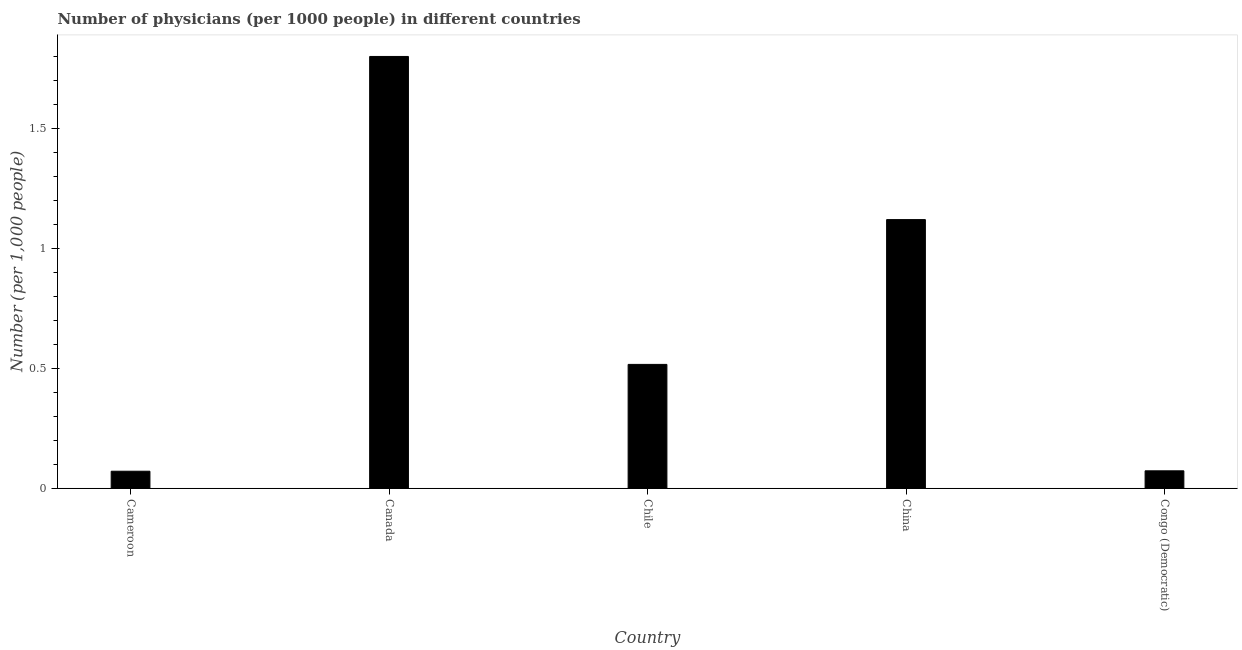Does the graph contain grids?
Your response must be concise. No. What is the title of the graph?
Your answer should be compact. Number of physicians (per 1000 people) in different countries. What is the label or title of the Y-axis?
Offer a very short reply. Number (per 1,0 people). What is the number of physicians in Congo (Democratic)?
Your answer should be very brief. 0.07. Across all countries, what is the maximum number of physicians?
Your answer should be compact. 1.8. Across all countries, what is the minimum number of physicians?
Your response must be concise. 0.07. In which country was the number of physicians maximum?
Offer a very short reply. Canada. In which country was the number of physicians minimum?
Keep it short and to the point. Cameroon. What is the sum of the number of physicians?
Offer a very short reply. 3.58. What is the difference between the number of physicians in Cameroon and Congo (Democratic)?
Provide a succinct answer. -0. What is the average number of physicians per country?
Offer a very short reply. 0.72. What is the median number of physicians?
Your response must be concise. 0.52. In how many countries, is the number of physicians greater than 0.6 ?
Provide a succinct answer. 2. Is the number of physicians in China less than that in Congo (Democratic)?
Offer a terse response. No. What is the difference between the highest and the second highest number of physicians?
Provide a short and direct response. 0.68. Is the sum of the number of physicians in Cameroon and Chile greater than the maximum number of physicians across all countries?
Keep it short and to the point. No. What is the difference between the highest and the lowest number of physicians?
Offer a terse response. 1.73. In how many countries, is the number of physicians greater than the average number of physicians taken over all countries?
Provide a succinct answer. 2. Are the values on the major ticks of Y-axis written in scientific E-notation?
Your answer should be compact. No. What is the Number (per 1,000 people) of Cameroon?
Provide a short and direct response. 0.07. What is the Number (per 1,000 people) of Chile?
Provide a short and direct response. 0.52. What is the Number (per 1,000 people) in China?
Provide a succinct answer. 1.12. What is the Number (per 1,000 people) of Congo (Democratic)?
Provide a short and direct response. 0.07. What is the difference between the Number (per 1,000 people) in Cameroon and Canada?
Ensure brevity in your answer.  -1.73. What is the difference between the Number (per 1,000 people) in Cameroon and Chile?
Provide a short and direct response. -0.45. What is the difference between the Number (per 1,000 people) in Cameroon and China?
Offer a very short reply. -1.05. What is the difference between the Number (per 1,000 people) in Cameroon and Congo (Democratic)?
Provide a short and direct response. -0. What is the difference between the Number (per 1,000 people) in Canada and Chile?
Keep it short and to the point. 1.28. What is the difference between the Number (per 1,000 people) in Canada and China?
Your response must be concise. 0.68. What is the difference between the Number (per 1,000 people) in Canada and Congo (Democratic)?
Provide a succinct answer. 1.73. What is the difference between the Number (per 1,000 people) in Chile and China?
Ensure brevity in your answer.  -0.6. What is the difference between the Number (per 1,000 people) in Chile and Congo (Democratic)?
Ensure brevity in your answer.  0.44. What is the difference between the Number (per 1,000 people) in China and Congo (Democratic)?
Give a very brief answer. 1.05. What is the ratio of the Number (per 1,000 people) in Cameroon to that in Canada?
Provide a succinct answer. 0.04. What is the ratio of the Number (per 1,000 people) in Cameroon to that in Chile?
Provide a succinct answer. 0.14. What is the ratio of the Number (per 1,000 people) in Cameroon to that in China?
Keep it short and to the point. 0.06. What is the ratio of the Number (per 1,000 people) in Canada to that in Chile?
Keep it short and to the point. 3.49. What is the ratio of the Number (per 1,000 people) in Canada to that in China?
Make the answer very short. 1.61. What is the ratio of the Number (per 1,000 people) in Canada to that in Congo (Democratic)?
Provide a short and direct response. 24.73. What is the ratio of the Number (per 1,000 people) in Chile to that in China?
Offer a very short reply. 0.46. What is the ratio of the Number (per 1,000 people) in Chile to that in Congo (Democratic)?
Give a very brief answer. 7.09. What is the ratio of the Number (per 1,000 people) in China to that in Congo (Democratic)?
Provide a short and direct response. 15.38. 